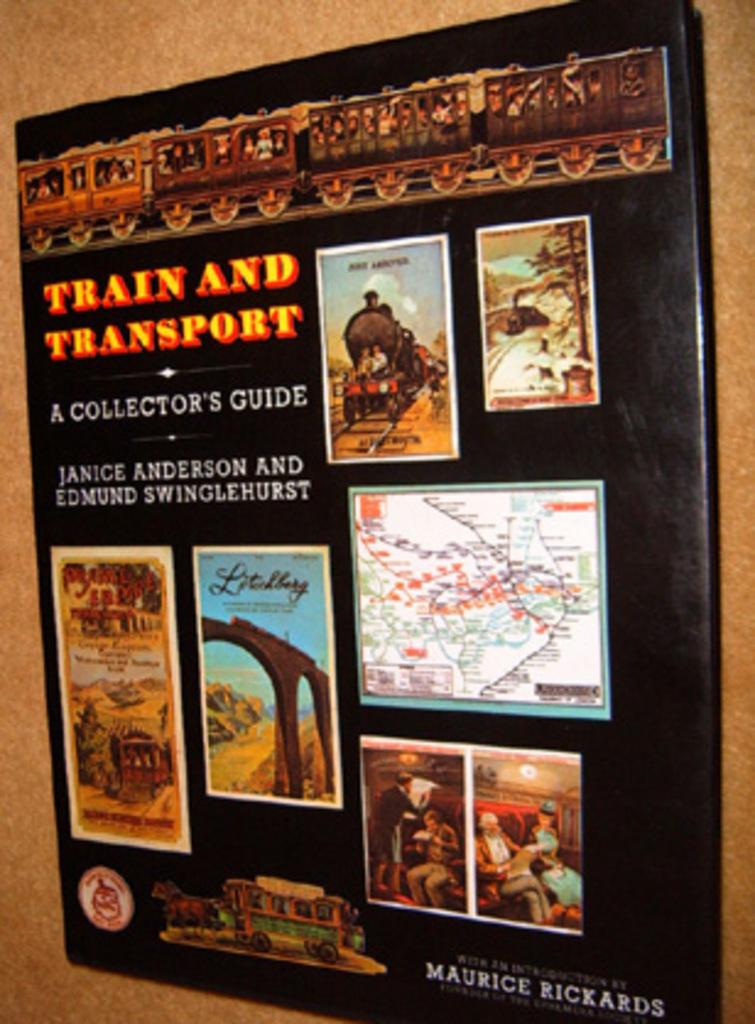What does it say on this poster?
Your answer should be very brief. Train and transport. What kind of transport vehicle is being centered here?
Provide a succinct answer. Train. 